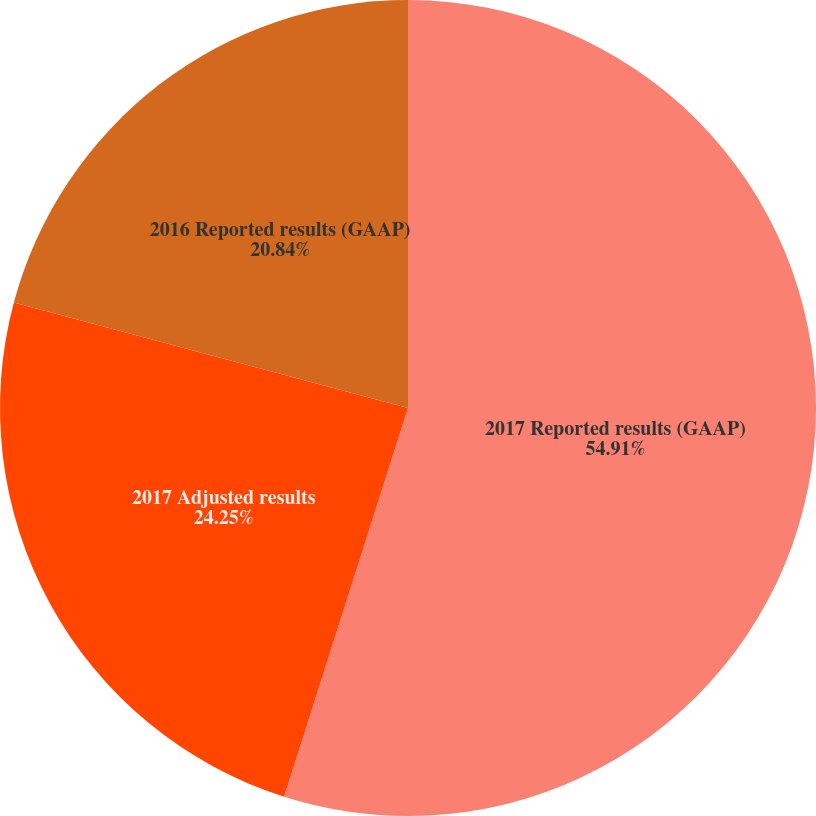Convert chart to OTSL. <chart><loc_0><loc_0><loc_500><loc_500><pie_chart><fcel>2017 Reported results (GAAP)<fcel>2017 Adjusted results<fcel>2016 Reported results (GAAP)<nl><fcel>54.91%<fcel>24.25%<fcel>20.84%<nl></chart> 